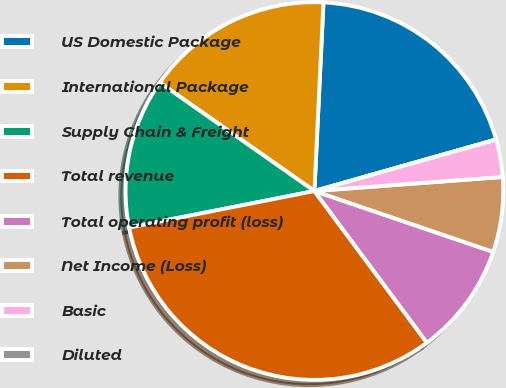<chart> <loc_0><loc_0><loc_500><loc_500><pie_chart><fcel>US Domestic Package<fcel>International Package<fcel>Supply Chain & Freight<fcel>Total revenue<fcel>Total operating profit (loss)<fcel>Net Income (Loss)<fcel>Basic<fcel>Diluted<nl><fcel>19.84%<fcel>16.03%<fcel>12.83%<fcel>32.06%<fcel>9.62%<fcel>6.41%<fcel>3.21%<fcel>0.0%<nl></chart> 